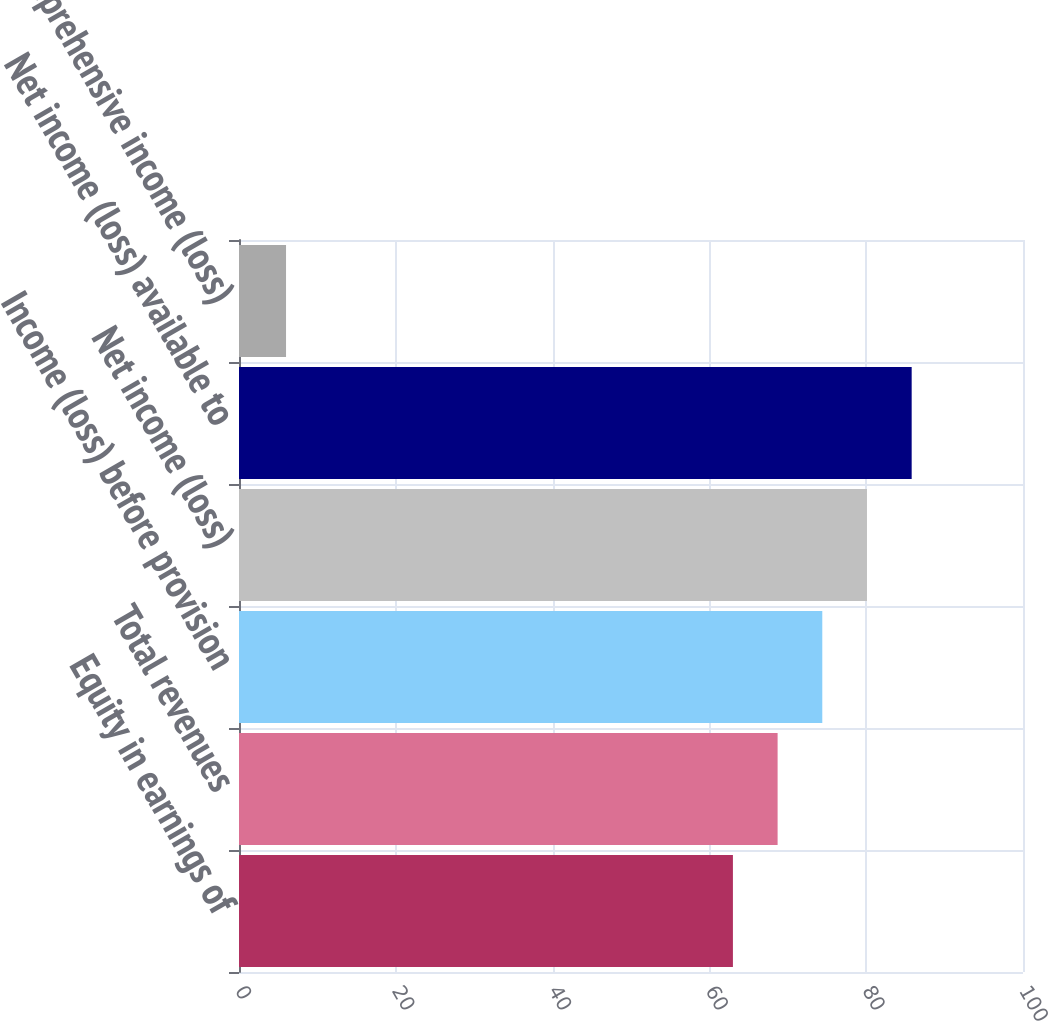<chart> <loc_0><loc_0><loc_500><loc_500><bar_chart><fcel>Equity in earnings of<fcel>Total revenues<fcel>Income (loss) before provision<fcel>Net income (loss)<fcel>Net income (loss) available to<fcel>Comprehensive income (loss)<nl><fcel>63<fcel>68.7<fcel>74.4<fcel>80.1<fcel>85.8<fcel>6<nl></chart> 